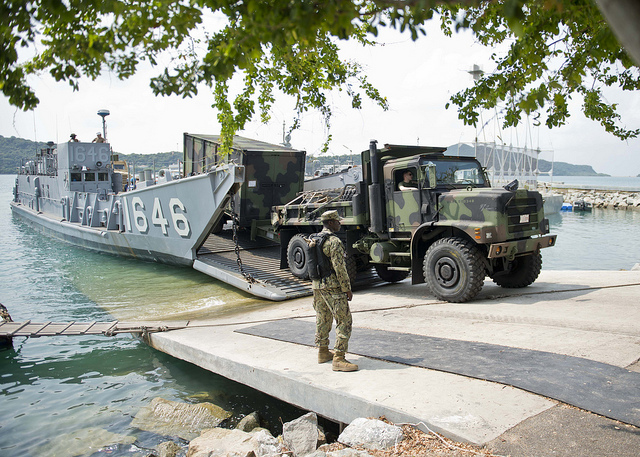What can be inferred about the mission of the military personnel in the image? Based on the image, it appears that the military personnel are engaged in an operation involving the transportation of armored vehicles. The scene shows military trucks being unloaded from a landing craft onto a dock, indicating logistical support or troop movements. One soldier is visible overseeing the process, equipped with a backpack, which suggests that the mission could also involve establishing a temporary base or supplying a stationed unit. The presence of such structured and coordinated activity implies that the military personnel are likely participating in a strategic deployment, possibly for training exercises, disaster relief operations, or reinforcing a particular location. 